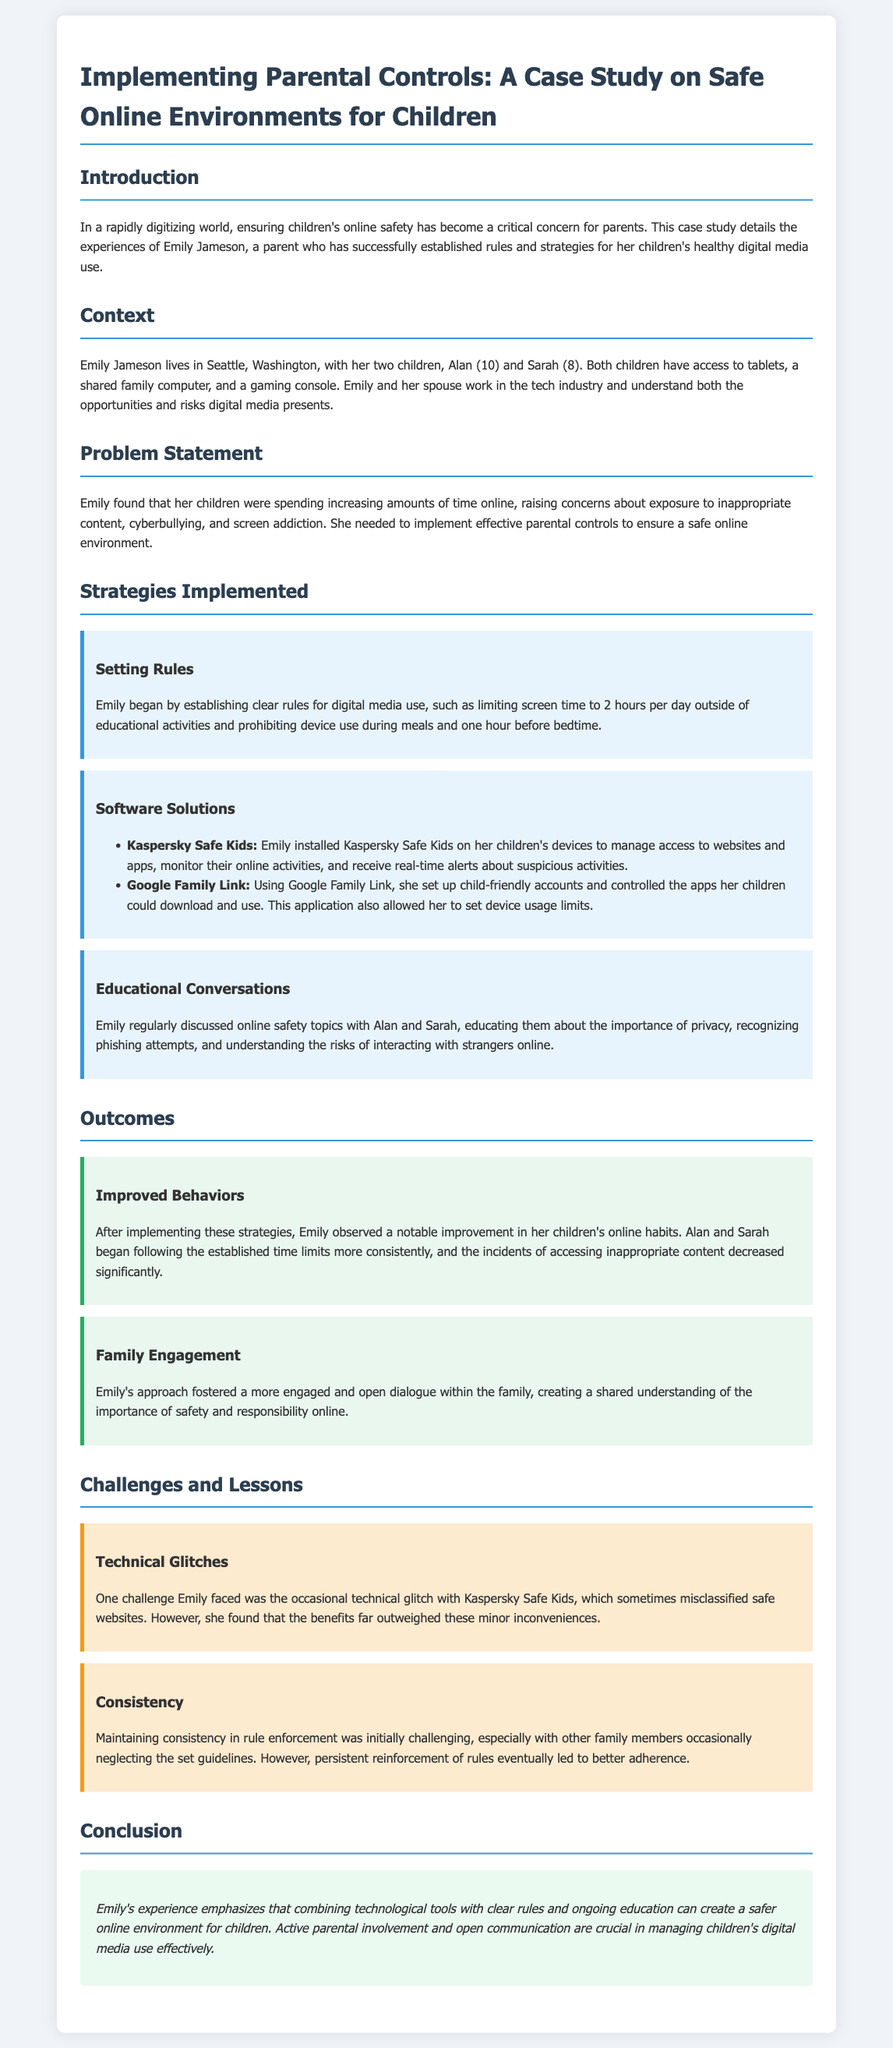what are the names of Emily's children? The document mentions Emily's children as Alan and Sarah.
Answer: Alan and Sarah how many hours of screen time are allowed? Emily established a rule to limit screen time to 2 hours per day outside of educational activities.
Answer: 2 hours what parental control software did Emily use for monitoring? The document specifically names Kaspersky Safe Kids as a software solution for managing online activities.
Answer: Kaspersky Safe Kids what was a challenge Emily faced with the software? The document describes that Emily faced occasional technical glitches with Kaspersky Safe Kids that misclassified safe websites.
Answer: Technical glitches which city does Emily live in? The case study states that Emily Jameson lives in Seattle, Washington.
Answer: Seattle what approach improved family engagement? Emily’s approach included educating her children about online safety, which fostered more engagement and open dialogue within the family.
Answer: Educational conversations how old is Sarah? The document indicates that Sarah is 8 years old.
Answer: 8 years what is the main conclusion of the case study? The conclusion emphasizes the importance of combining technological tools with rules and education for children's safety online.
Answer: Active parental involvement and open communication what did Emily prohibit during meals? The document states that Emily prohibited device use during meals, emphasizing a rule to restrict their use in that context.
Answer: Device use 